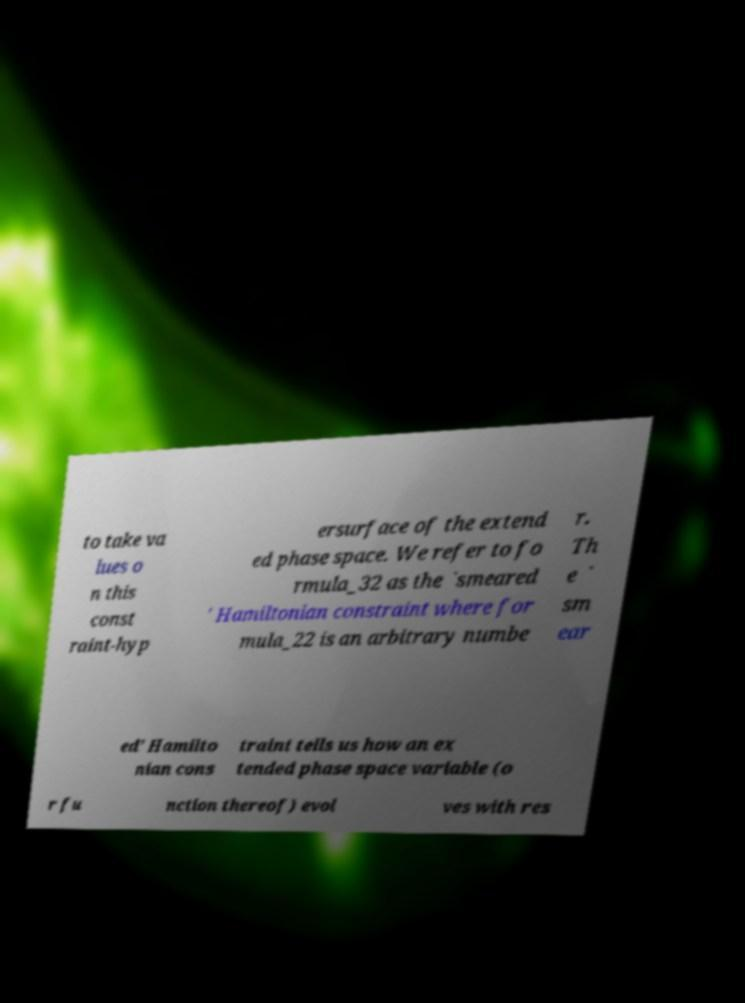Can you read and provide the text displayed in the image?This photo seems to have some interesting text. Can you extract and type it out for me? to take va lues o n this const raint-hyp ersurface of the extend ed phase space. We refer to fo rmula_32 as the `smeared ' Hamiltonian constraint where for mula_22 is an arbitrary numbe r. Th e ` sm ear ed' Hamilto nian cons traint tells us how an ex tended phase space variable (o r fu nction thereof) evol ves with res 